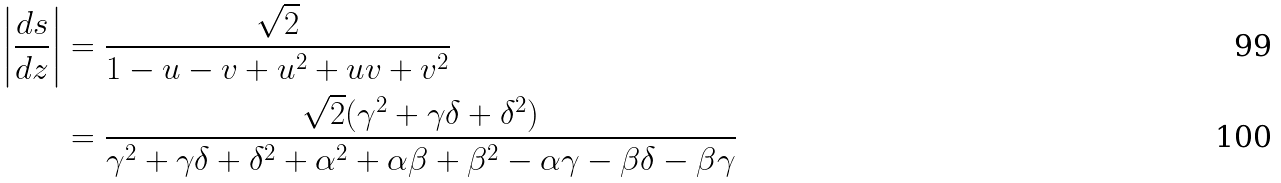<formula> <loc_0><loc_0><loc_500><loc_500>\left | \frac { d s } { d z } \right | & = \frac { \sqrt { 2 } } { 1 - u - v + u ^ { 2 } + u v + v ^ { 2 } } \\ & = \frac { \sqrt { 2 } ( \gamma ^ { 2 } + \gamma \delta + \delta ^ { 2 } ) } { \gamma ^ { 2 } + \gamma \delta + \delta ^ { 2 } + \alpha ^ { 2 } + \alpha \beta + \beta ^ { 2 } - \alpha \gamma - \beta \delta - \beta \gamma }</formula> 